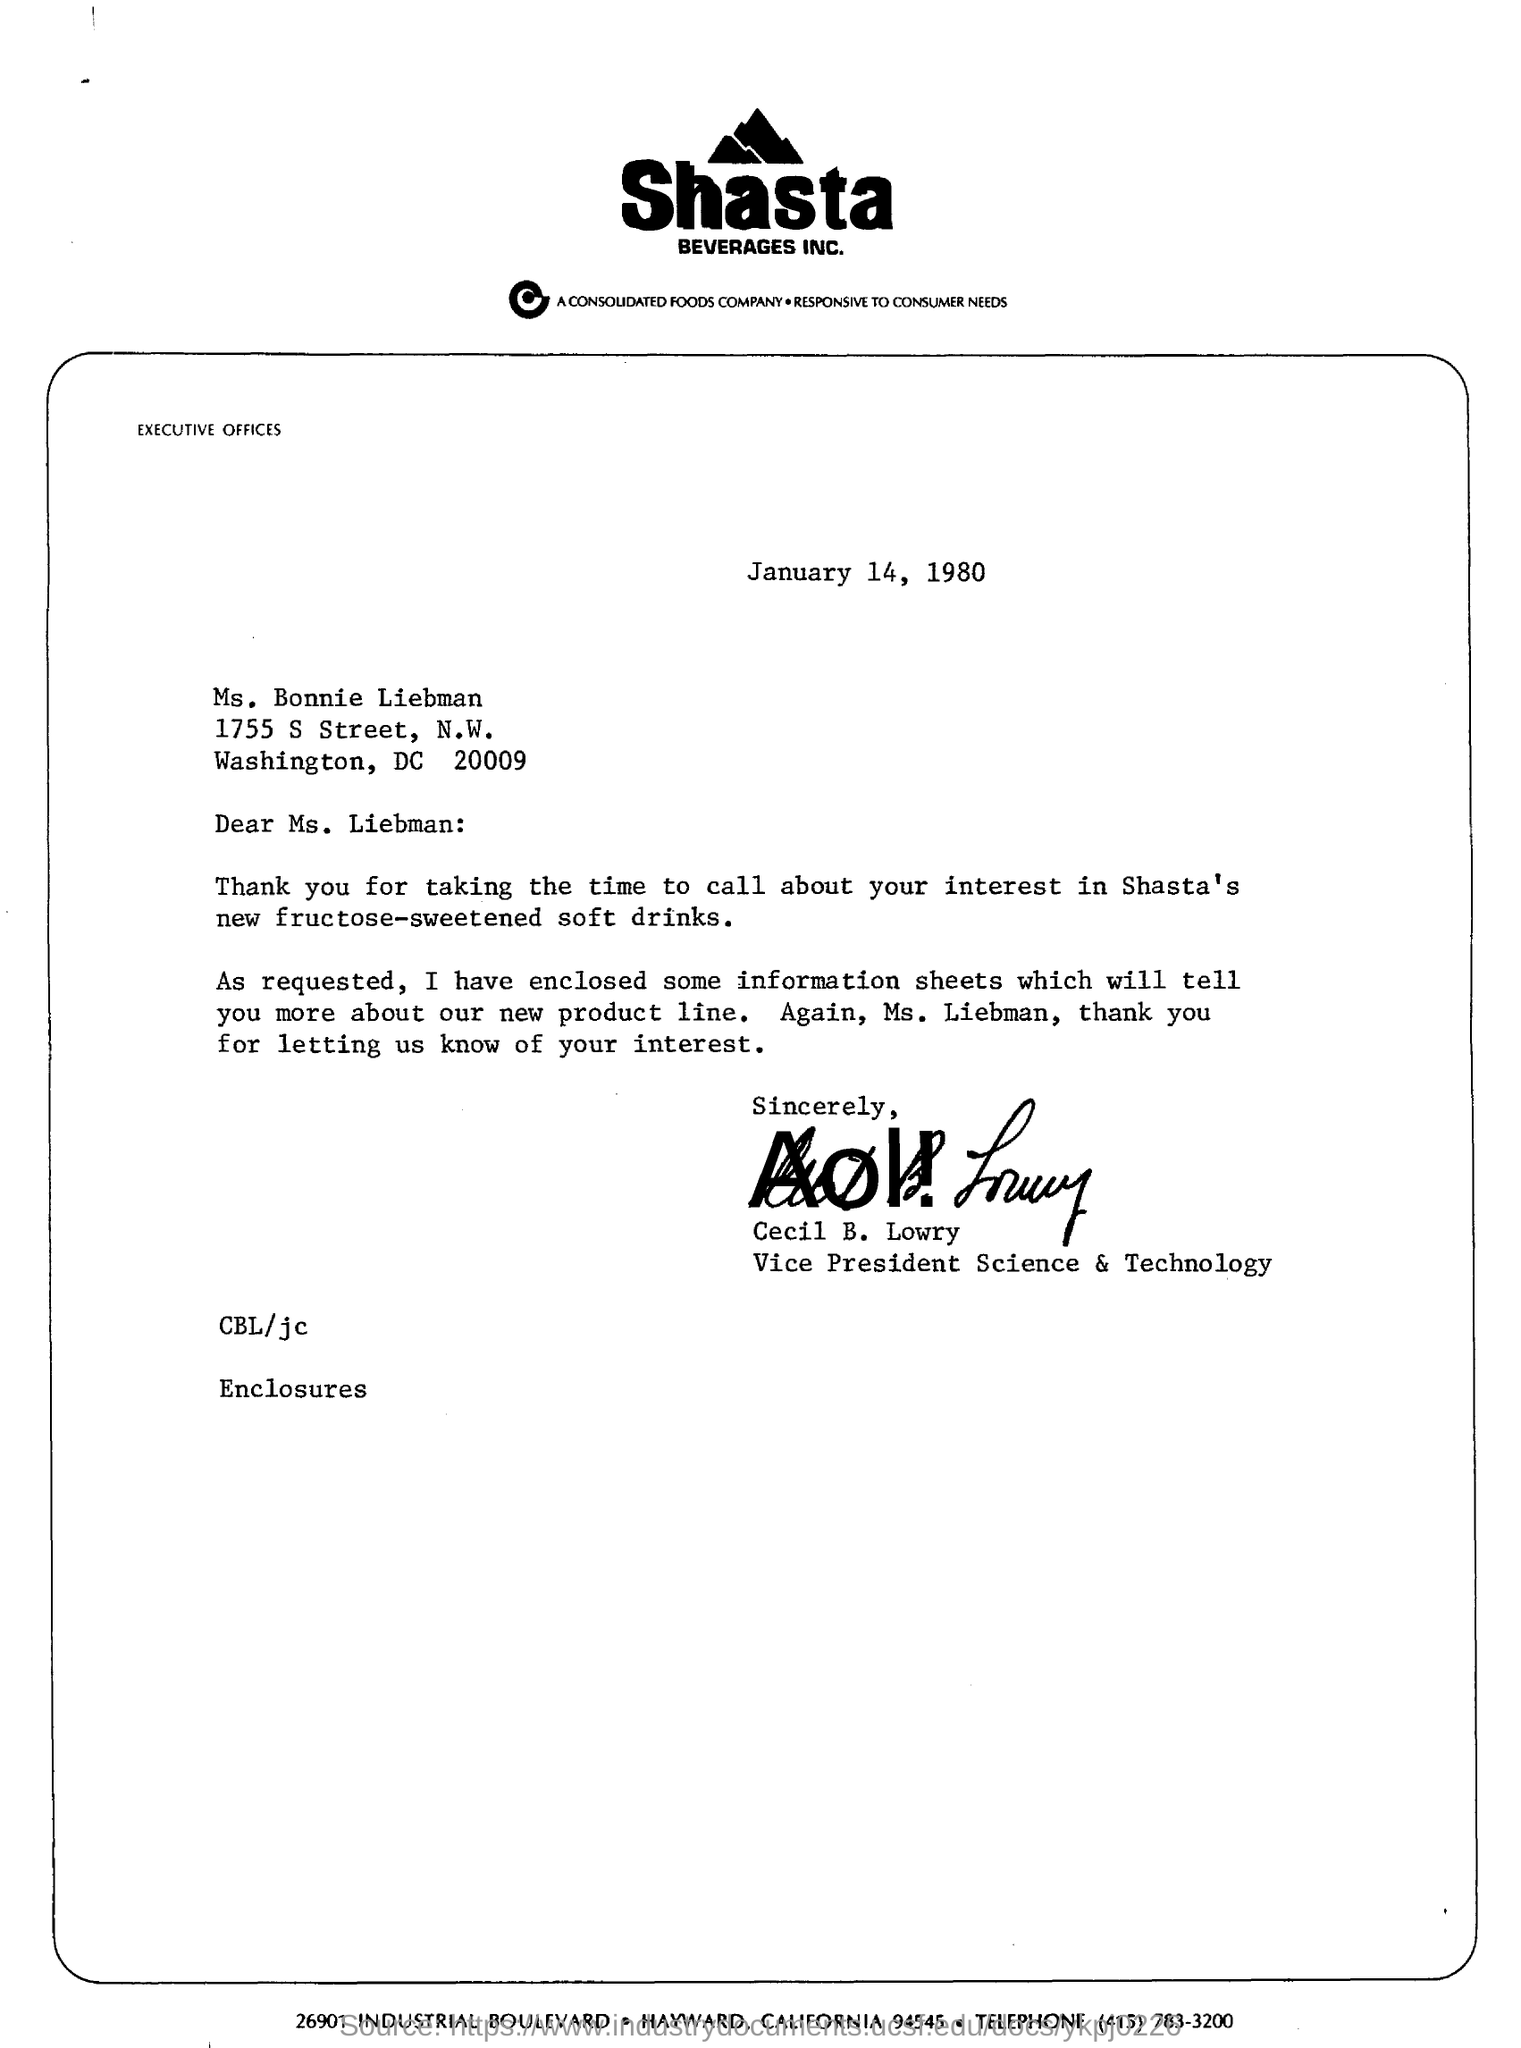Draw attention to some important aspects in this diagram. Cecil B. Lowry is the vice president of Shasta Beverages. The letter is addressed to Ms. Bonnie Liebman. The date mentioned in this letter is January 14, 1980. Shasta Beverages Inc. is the name of the company. 